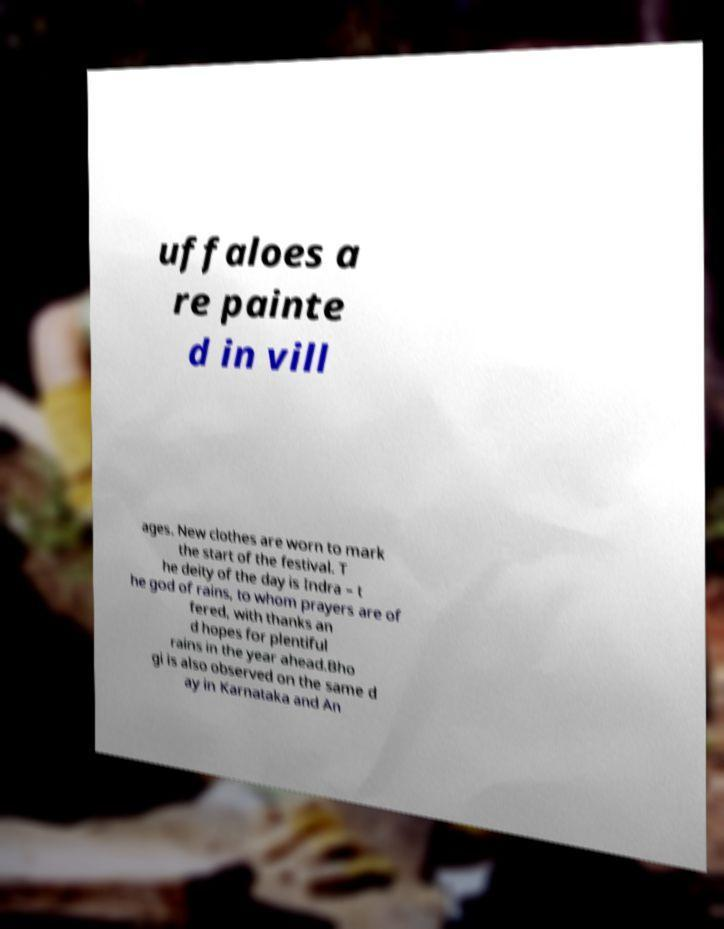Please read and relay the text visible in this image. What does it say? uffaloes a re painte d in vill ages. New clothes are worn to mark the start of the festival. T he deity of the day is Indra – t he god of rains, to whom prayers are of fered, with thanks an d hopes for plentiful rains in the year ahead.Bho gi is also observed on the same d ay in Karnataka and An 